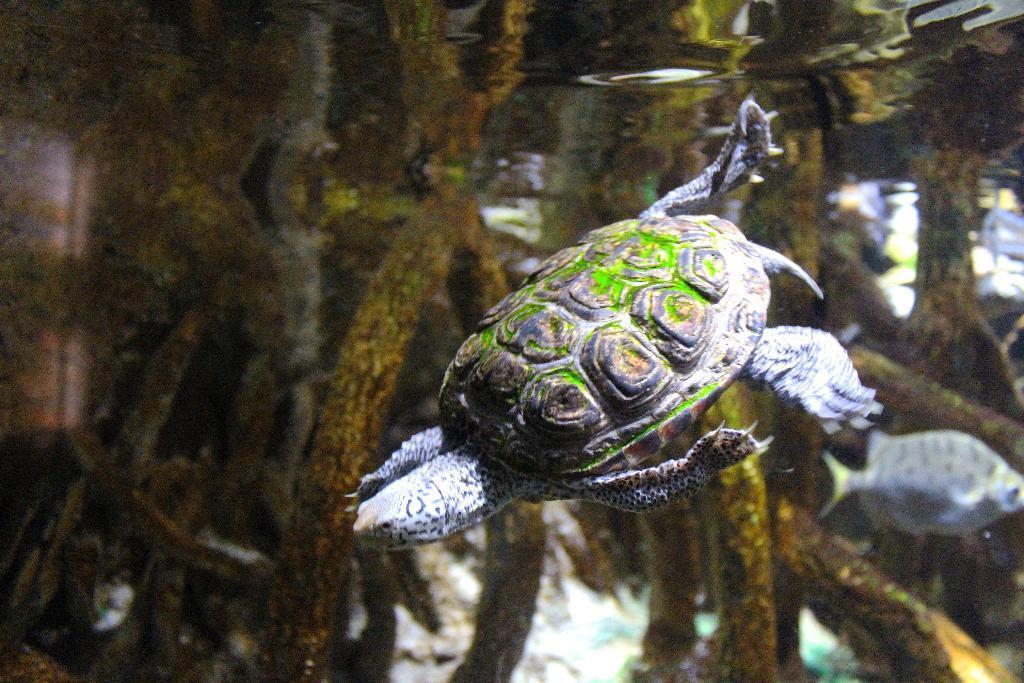Describe this image in one or two sentences. In this image we can see a tortoise, and a fish in the water, also we can see underwater plants. 